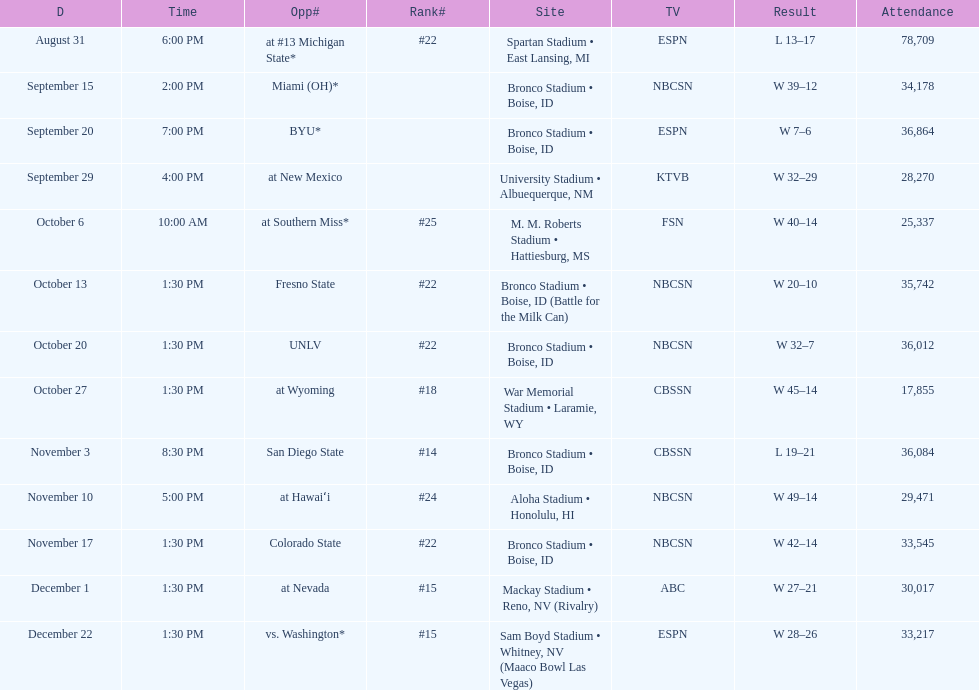Which team has the highest rank among those listed? San Diego State. 